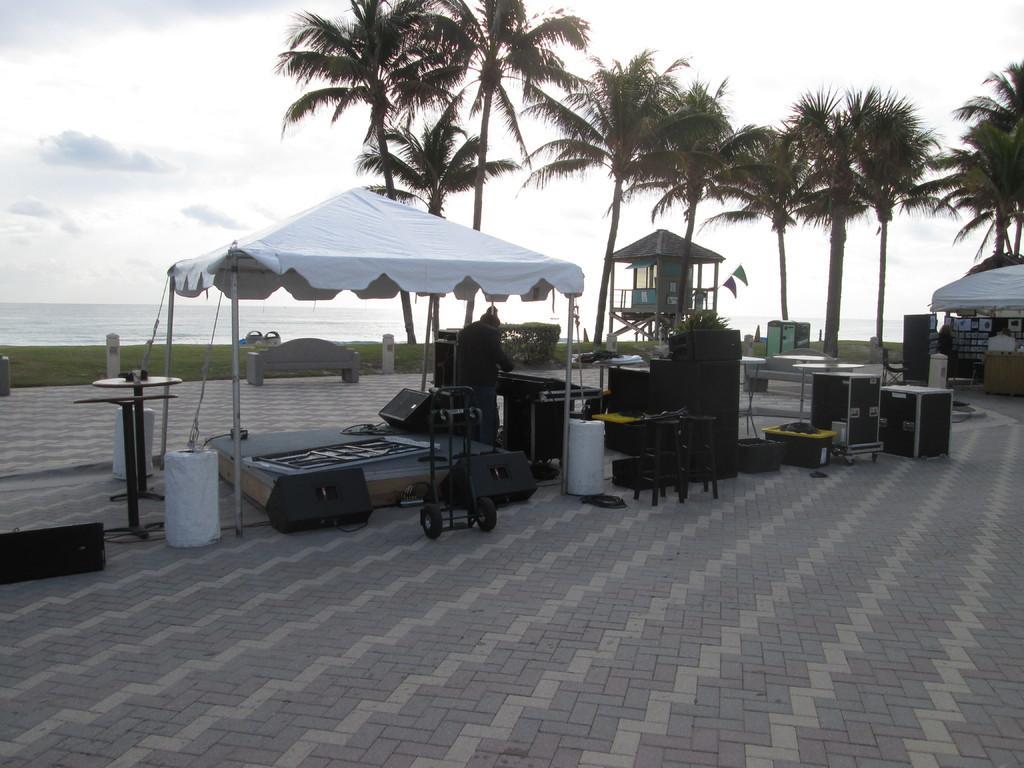Can you describe this image briefly? In this image there is a tent in the middle. Below the text there is a stage on which there are speakers and some boxes. In the background there are tall trees. At the top there is the sky. On the right side there is another tent under which there are banners. There is water in the background. 